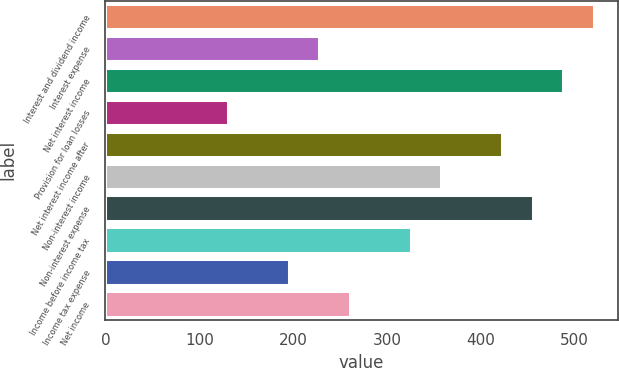Convert chart to OTSL. <chart><loc_0><loc_0><loc_500><loc_500><bar_chart><fcel>Interest and dividend income<fcel>Interest expense<fcel>Net interest income<fcel>Provision for loan losses<fcel>Net interest income after<fcel>Non-interest income<fcel>Non-interest expense<fcel>Income before income tax<fcel>Income tax expense<fcel>Net income<nl><fcel>520.19<fcel>227.66<fcel>487.69<fcel>130.16<fcel>422.69<fcel>357.69<fcel>455.19<fcel>325.18<fcel>195.16<fcel>260.16<nl></chart> 